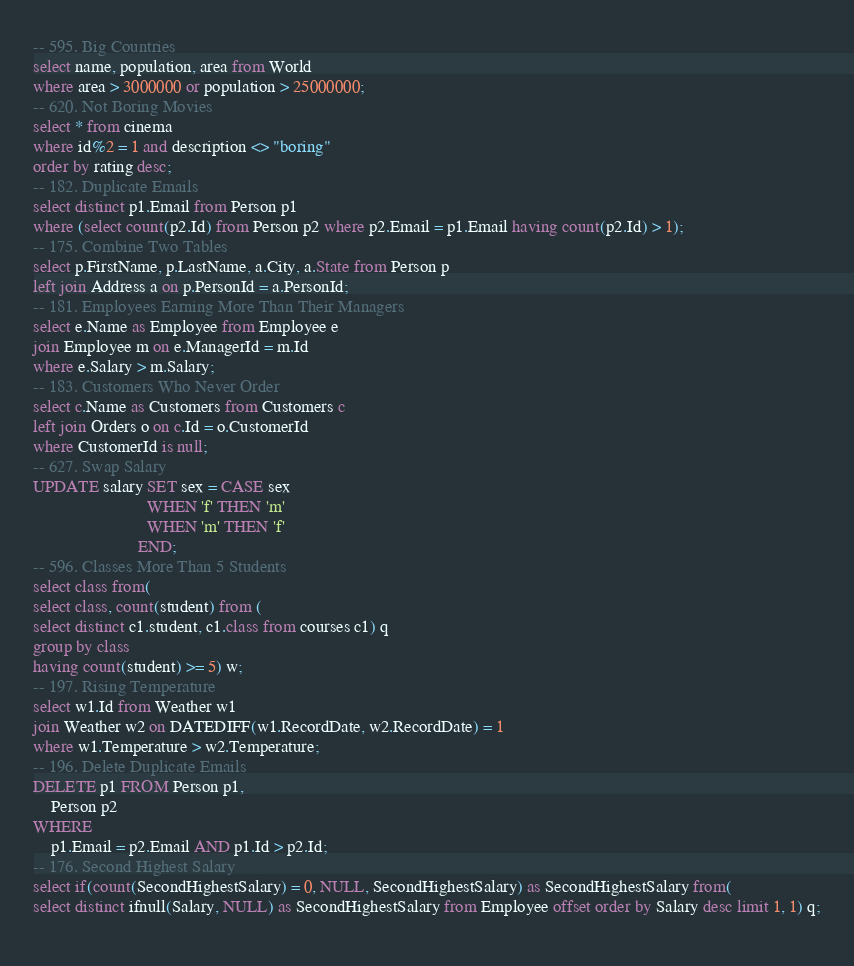<code> <loc_0><loc_0><loc_500><loc_500><_SQL_>-- 595. Big Countries
select name, population, area from World
where area > 3000000 or population > 25000000;
-- 620. Not Boring Movies
select * from cinema
where id%2 = 1 and description <> "boring"
order by rating desc;
-- 182. Duplicate Emails
select distinct p1.Email from Person p1
where (select count(p2.Id) from Person p2 where p2.Email = p1.Email having count(p2.Id) > 1);
-- 175. Combine Two Tables
select p.FirstName, p.LastName, a.City, a.State from Person p
left join Address a on p.PersonId = a.PersonId;
-- 181. Employees Earning More Than Their Managers
select e.Name as Employee from Employee e
join Employee m on e.ManagerId = m.Id
where e.Salary > m.Salary;
-- 183. Customers Who Never Order
select c.Name as Customers from Customers c
left join Orders o on c.Id = o.CustomerId
where CustomerId is null;
-- 627. Swap Salary
UPDATE salary SET sex = CASE sex 
                          WHEN 'f' THEN 'm' 
                          WHEN 'm' THEN 'f' 
                        END;
-- 596. Classes More Than 5 Students
select class from(
select class, count(student) from (
select distinct c1.student, c1.class from courses c1) q
group by class
having count(student) >= 5) w;
-- 197. Rising Temperature
select w1.Id from Weather w1
join Weather w2 on DATEDIFF(w1.RecordDate, w2.RecordDate) = 1
where w1.Temperature > w2.Temperature;
-- 196. Delete Duplicate Emails
DELETE p1 FROM Person p1,
    Person p2
WHERE
    p1.Email = p2.Email AND p1.Id > p2.Id;
-- 176. Second Highest Salary
select if(count(SecondHighestSalary) = 0, NULL, SecondHighestSalary) as SecondHighestSalary from(
select distinct ifnull(Salary, NULL) as SecondHighestSalary from Employee offset order by Salary desc limit 1, 1) q;
    </code> 